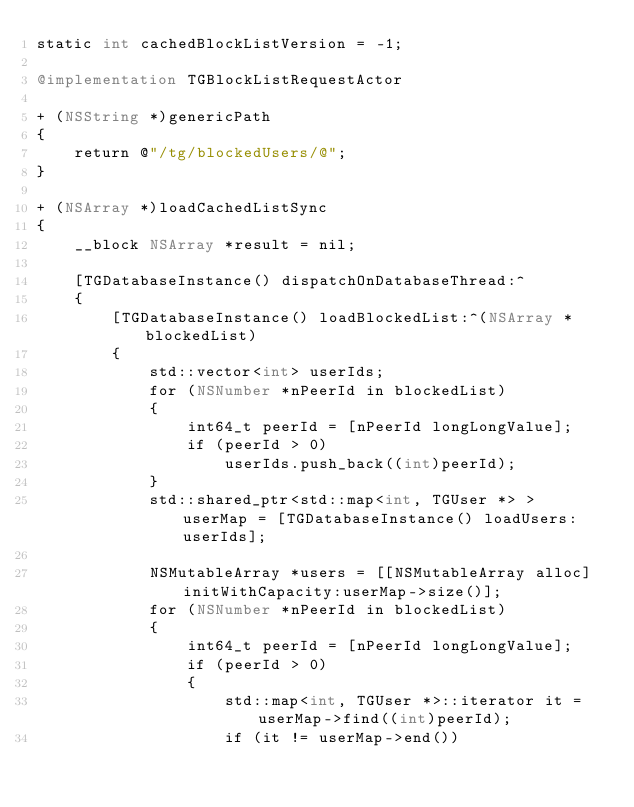Convert code to text. <code><loc_0><loc_0><loc_500><loc_500><_ObjectiveC_>static int cachedBlockListVersion = -1;

@implementation TGBlockListRequestActor

+ (NSString *)genericPath
{
    return @"/tg/blockedUsers/@";
}

+ (NSArray *)loadCachedListSync
{
    __block NSArray *result = nil;
    
    [TGDatabaseInstance() dispatchOnDatabaseThread:^
    {
        [TGDatabaseInstance() loadBlockedList:^(NSArray *blockedList)
        {
            std::vector<int> userIds;
            for (NSNumber *nPeerId in blockedList)
            {
                int64_t peerId = [nPeerId longLongValue];
                if (peerId > 0)
                    userIds.push_back((int)peerId);
            }
            std::shared_ptr<std::map<int, TGUser *> > userMap = [TGDatabaseInstance() loadUsers:userIds];
            
            NSMutableArray *users = [[NSMutableArray alloc] initWithCapacity:userMap->size()];
            for (NSNumber *nPeerId in blockedList)
            {
                int64_t peerId = [nPeerId longLongValue];
                if (peerId > 0)
                {
                    std::map<int, TGUser *>::iterator it = userMap->find((int)peerId);
                    if (it != userMap->end())</code> 